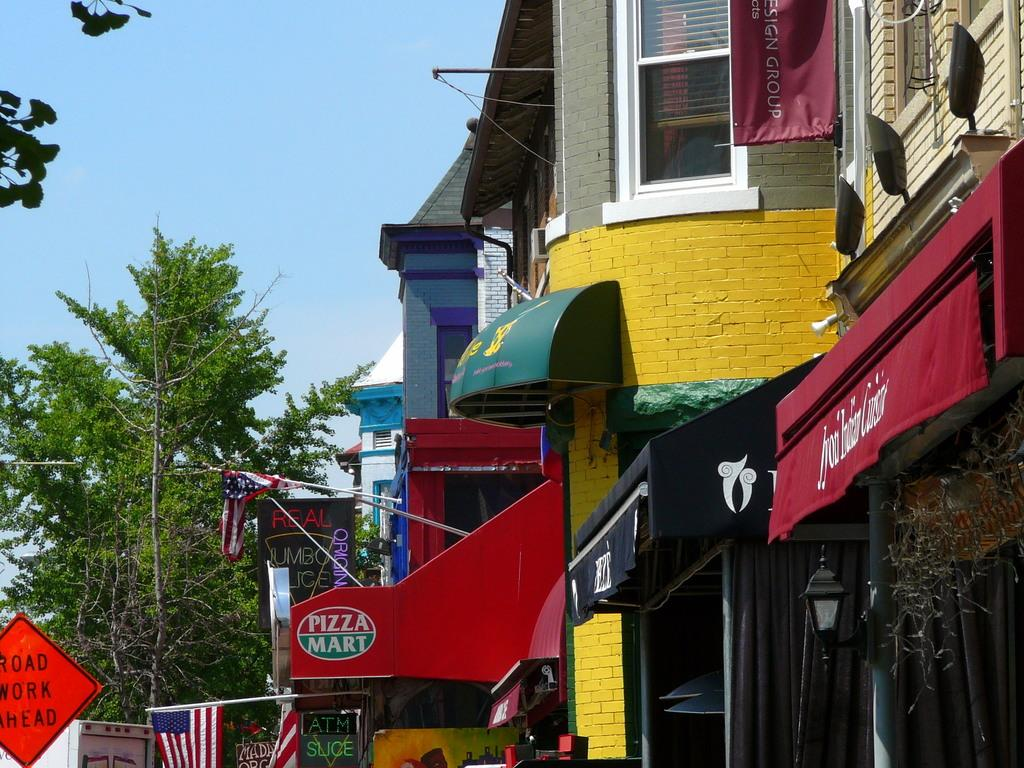What type of structures can be seen in the image? There are buildings in the image. What additional items are present in the image? Banners, boards, flags, sign boards, and name boards are visible in the image. What type of vegetation is present in the image? Trees are present in the image. What can be seen illuminating the scene? Lights are visible in the image. What is visible at the top of the image? The sky is visible at the top of the image. Is there a volcano erupting in the image? No, there is no volcano present in the image. Can you see a group of people gathered around a pipe in the image? There is no pipe or group of people present in the image. 